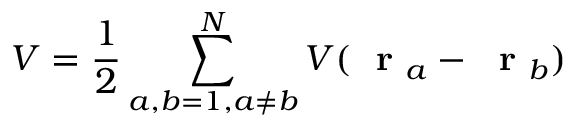<formula> <loc_0><loc_0><loc_500><loc_500>V = \frac { 1 } { 2 } \sum _ { a , b = 1 , a \ne b } ^ { N } V ( r _ { a } - r _ { b } )</formula> 